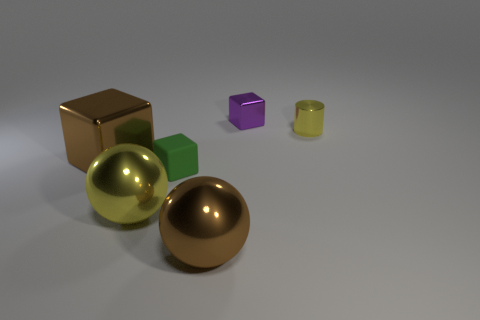How many objects are in the image? There are six objects in total in the image. They consist of two spheres, three cubes, and one cylinder. 